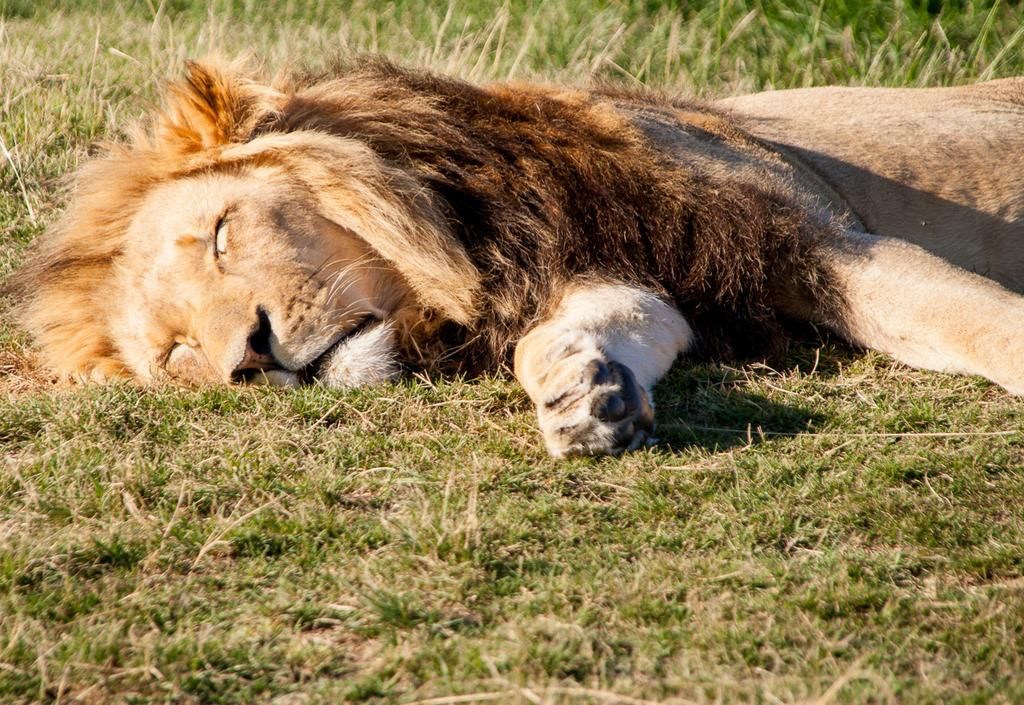What type of animal is in the image? There is a lion in the image. What type of natural environment is visible at the bottom of the image? There is grass visible at the bottom of the image. What type of art is the lion wearing in the image? The lion is not wearing any type of art or clothing in the image. Is there any indication that the lion is a slave in the image? There is no indication that the lion is a slave or subject to any form of servitude in the image. 